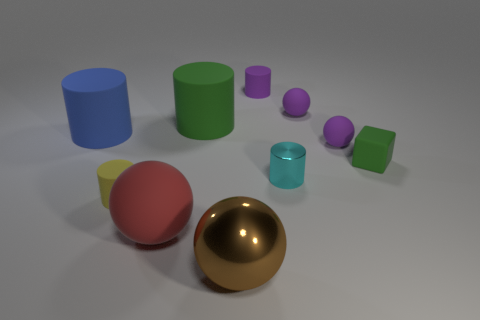What can you infer about the material of the shiny gold object? The shiny gold object appears to have a reflective and smooth surface, suggesting it's made of a material like polished metal, which is different from the matt finish of the other objects that suggests a rubbery texture. 